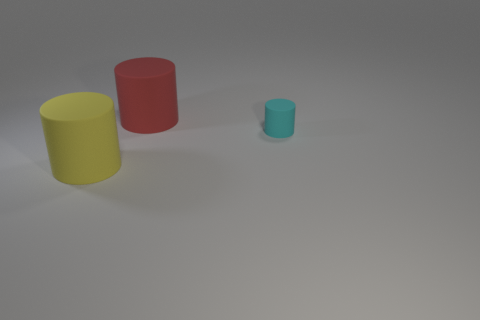Is there anything else that is the same size as the cyan matte object?
Ensure brevity in your answer.  No. There is a small cylinder; is its color the same as the matte thing behind the tiny cylinder?
Provide a short and direct response. No. What material is the large thing that is behind the large matte object on the left side of the object behind the small matte cylinder?
Provide a short and direct response. Rubber. Is the shape of the big thing behind the small rubber object the same as  the big yellow matte thing?
Provide a succinct answer. Yes. What material is the object that is in front of the small cyan thing?
Provide a succinct answer. Rubber. What number of matte things are either large things or purple objects?
Keep it short and to the point. 2. Are there any other matte cylinders of the same size as the yellow cylinder?
Keep it short and to the point. Yes. Are there more big things that are behind the yellow thing than tiny cubes?
Offer a terse response. Yes. How many big objects are either yellow cylinders or red things?
Make the answer very short. 2. What number of big red matte objects have the same shape as the cyan matte object?
Keep it short and to the point. 1. 